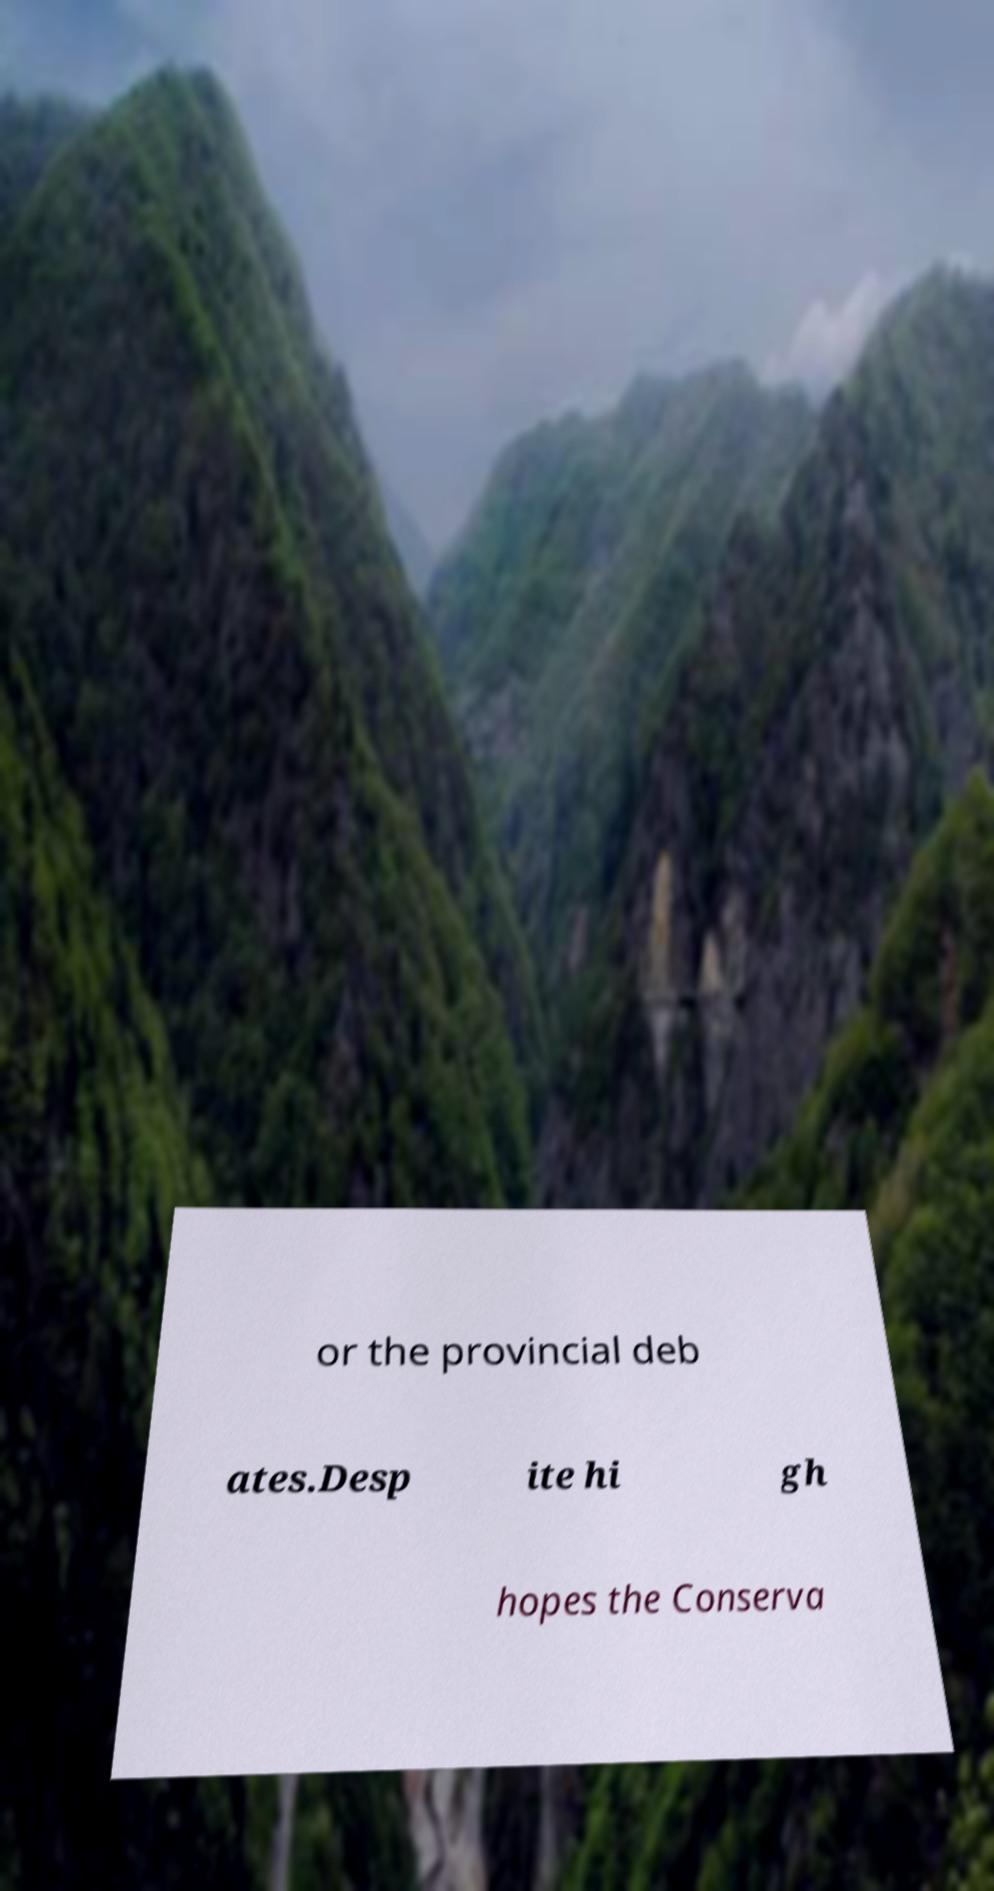I need the written content from this picture converted into text. Can you do that? or the provincial deb ates.Desp ite hi gh hopes the Conserva 